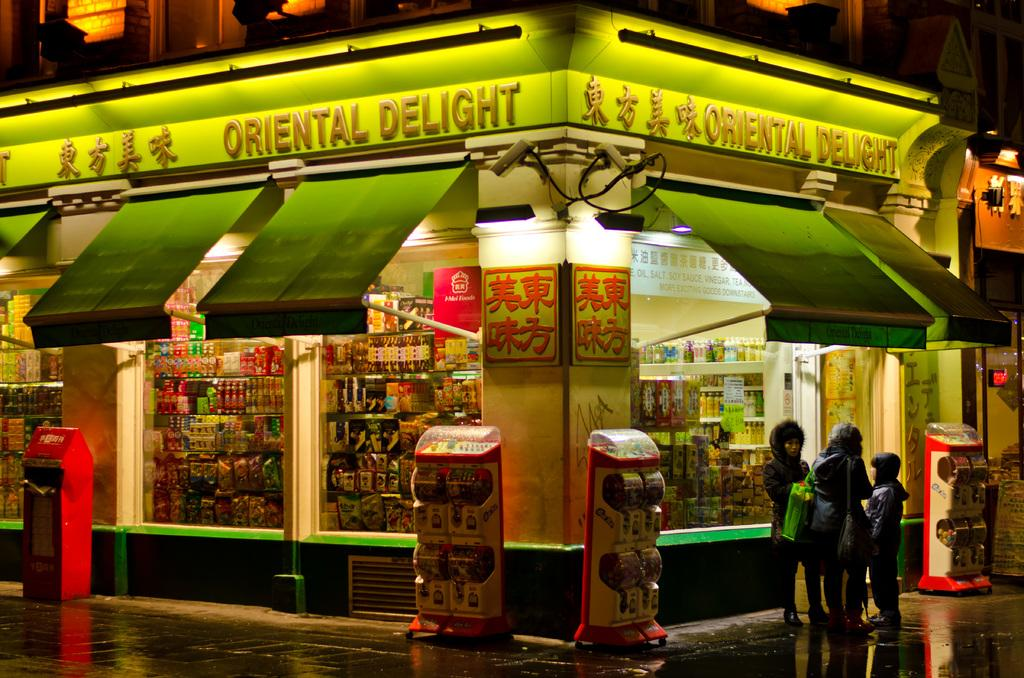Provide a one-sentence caption for the provided image. Store front on the corner that is called Oriental Delight. 